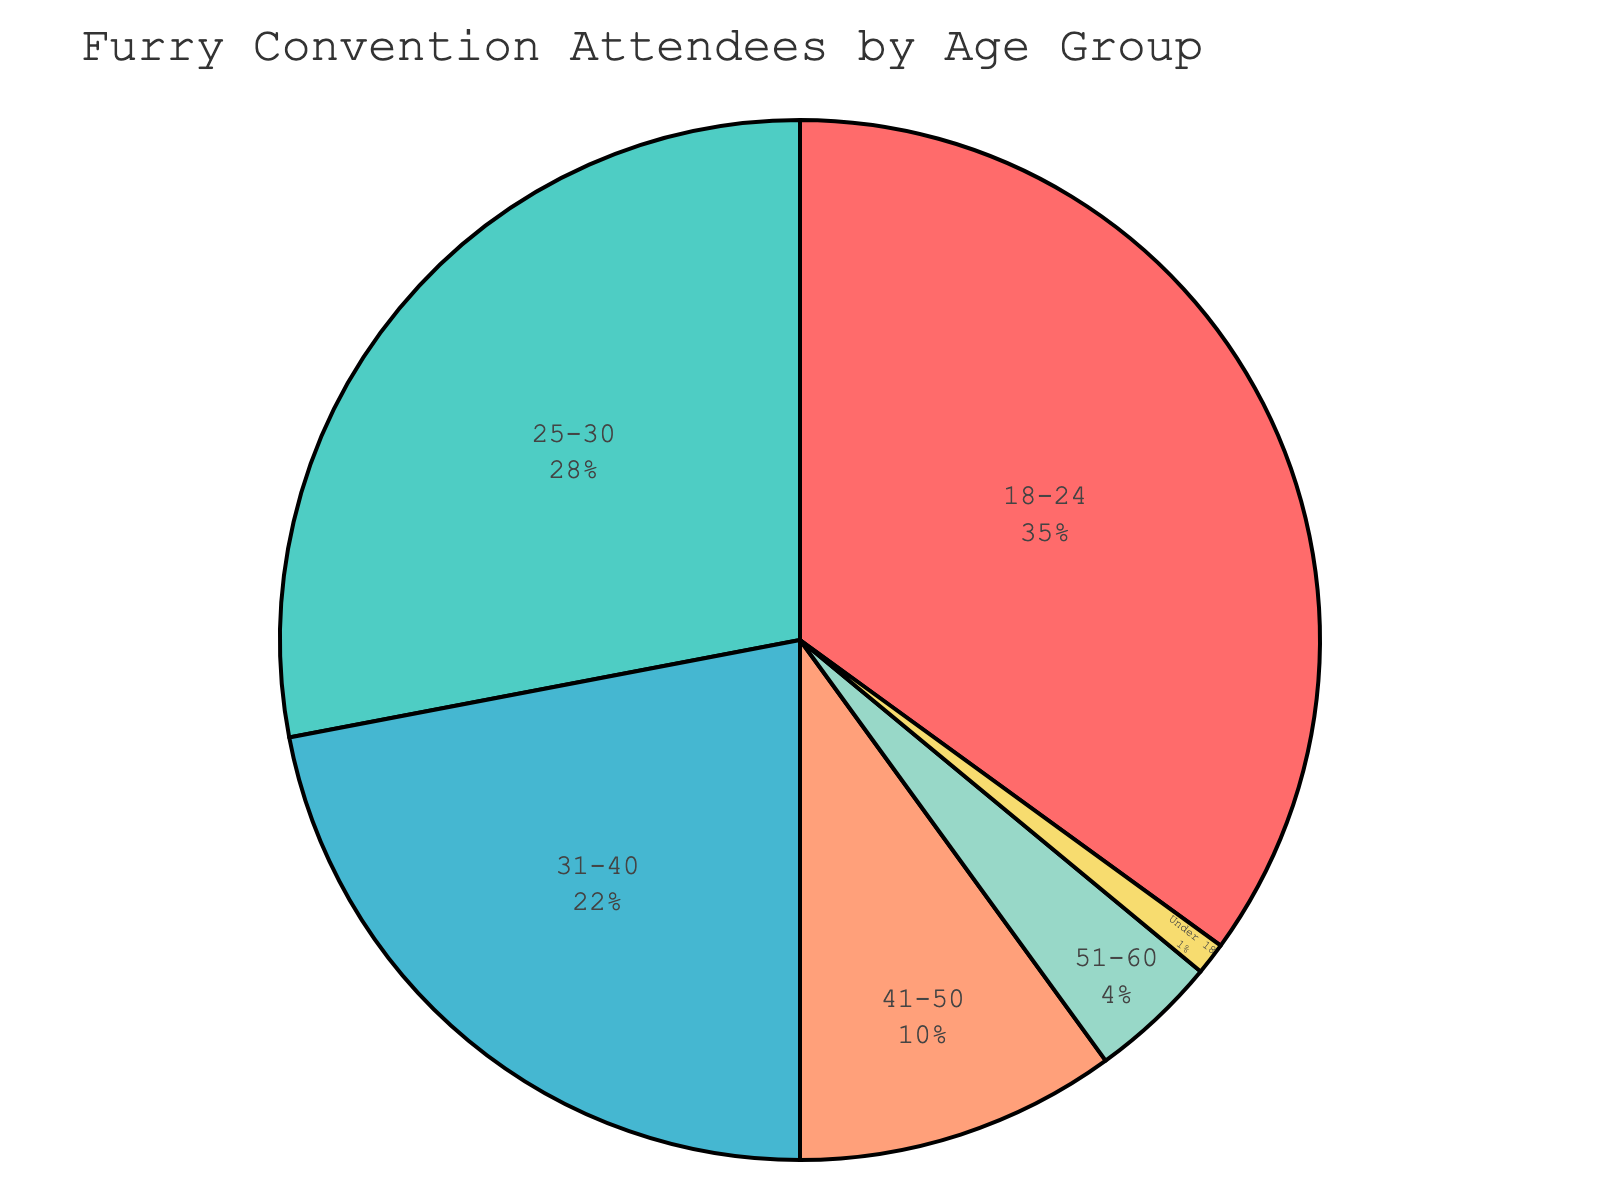Which age group has the highest percentage of attendees? According to the chart, the age group with the highest percentage is 18-24.
Answer: 18-24 What is the combined percentage of attendees who are 40 years old or younger? Summing the percentages for the age groups Under 18, 18-24, 25-30, and 31-40 gives 1 + 35 + 28 + 22 = 86%.
Answer: 86% Which age group contributes the smallest percentage to the attendance? The age group Under 18 is the smallest, contributing 1% of the attendees.
Answer: Under 18 How much larger is the percentage of attendees aged 25-30 compared to those aged 31-40? Subtract the percentage of the 31-40 age group from that of the 25-30 age group: 28 - 22 = 6%.
Answer: 6% What is the difference in percentage between the 30 years and younger group (Under 18, 18-24, 25-30) and the 31 years and older group (31-40, 41-50, 51-60)? Sum the percentages for each group: Under 18, 18-24, and 25-30 is 1 + 35 + 28 = 64%. The sum for 31-40, 41-50, and 51-60 is 22 + 10 + 4 = 36%. The difference is 64 - 36 = 28%.
Answer: 28% Which color represents the attendees aged 31-40 on the pie chart? The color representing the 31-40 age group is turquoise.
Answer: turquoise How much higher is the percentage of attendees aged 18-24 compared to those aged 41-50? The difference in their percentages is: 35 - 10 = 25%.
Answer: 25% Which two age groups together account for over half of the attendees? Adding the percentages of age groups 18-24 and 25-30 gives 35 + 28 = 63%, which is over half of the total.
Answer: 18-24 and 25-30 If you combine the percentages of the two groups with the fewest attendees, what percentage do they make up? Adding the percentages of Under 18 and 51-60: 1 + 4 = 5%.
Answer: 5% What percentage of attendees is aged between 31 and 50? Adding the percentages for age groups 31-40 and 41-50 gives: 22 + 10 = 32%.
Answer: 32% 